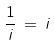Convert formula to latex. <formula><loc_0><loc_0><loc_500><loc_500>\frac { 1 } { i } \, = \, i</formula> 